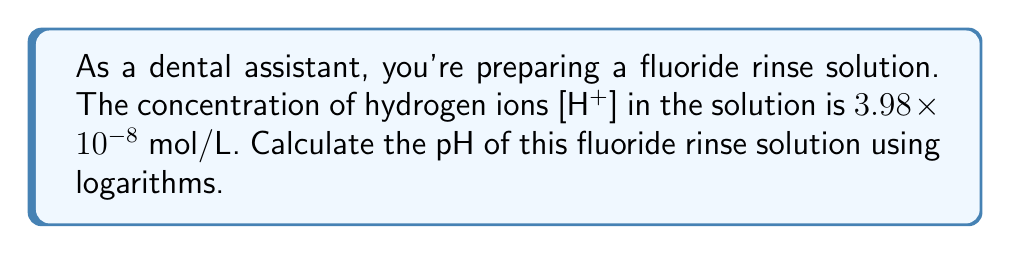Could you help me with this problem? To calculate the pH using logarithms, we'll follow these steps:

1) Recall the formula for pH:
   $pH = -\log_{10}[H^+]$

2) We're given $[H^+] = 3.98 \times 10^{-8}$ mol/L

3) Substituting this into the pH formula:
   $pH = -\log_{10}(3.98 \times 10^{-8})$

4) Using the properties of logarithms, we can split this:
   $pH = -(\log_{10}(3.98) + \log_{10}(10^{-8}))$

5) Simplify:
   $pH = -(\log_{10}(3.98) - 8)$

6) Calculate $\log_{10}(3.98)$ (use a calculator):
   $\log_{10}(3.98) \approx 0.6000$

7) Substituting back:
   $pH = -(0.6000 - 8) = -0.6000 + 8 = 7.4000$

8) Rounding to two decimal places:
   $pH \approx 7.40$

This pH indicates that the fluoride rinse solution is slightly alkaline, which is typical for many dental rinses to help neutralize acidic conditions in the mouth.
Answer: $7.40$ 